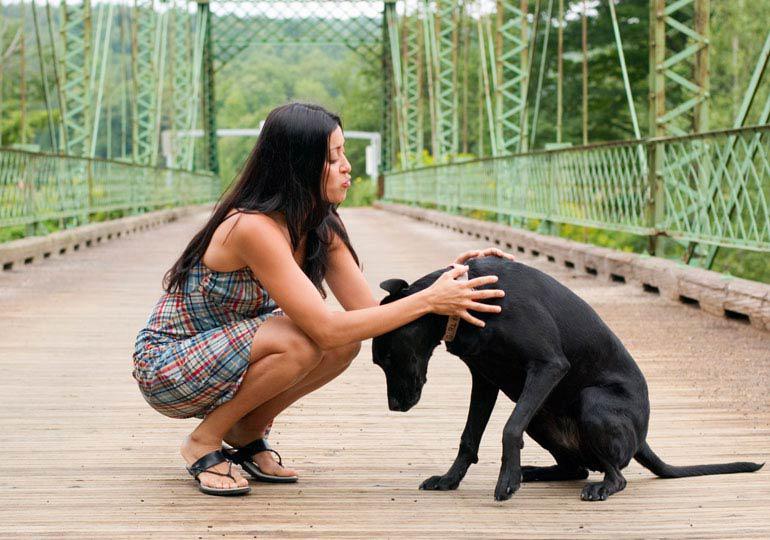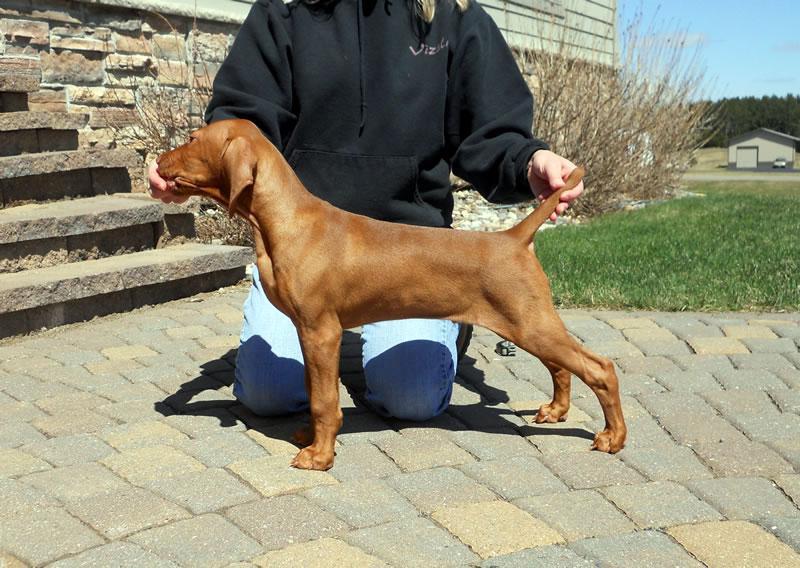The first image is the image on the left, the second image is the image on the right. Assess this claim about the two images: "The right image shows a person in blue jeans kneeling behind a leftward-facing dog standing in profile, with one hand on the dog's chin and the other hand on its tail.". Correct or not? Answer yes or no. Yes. 